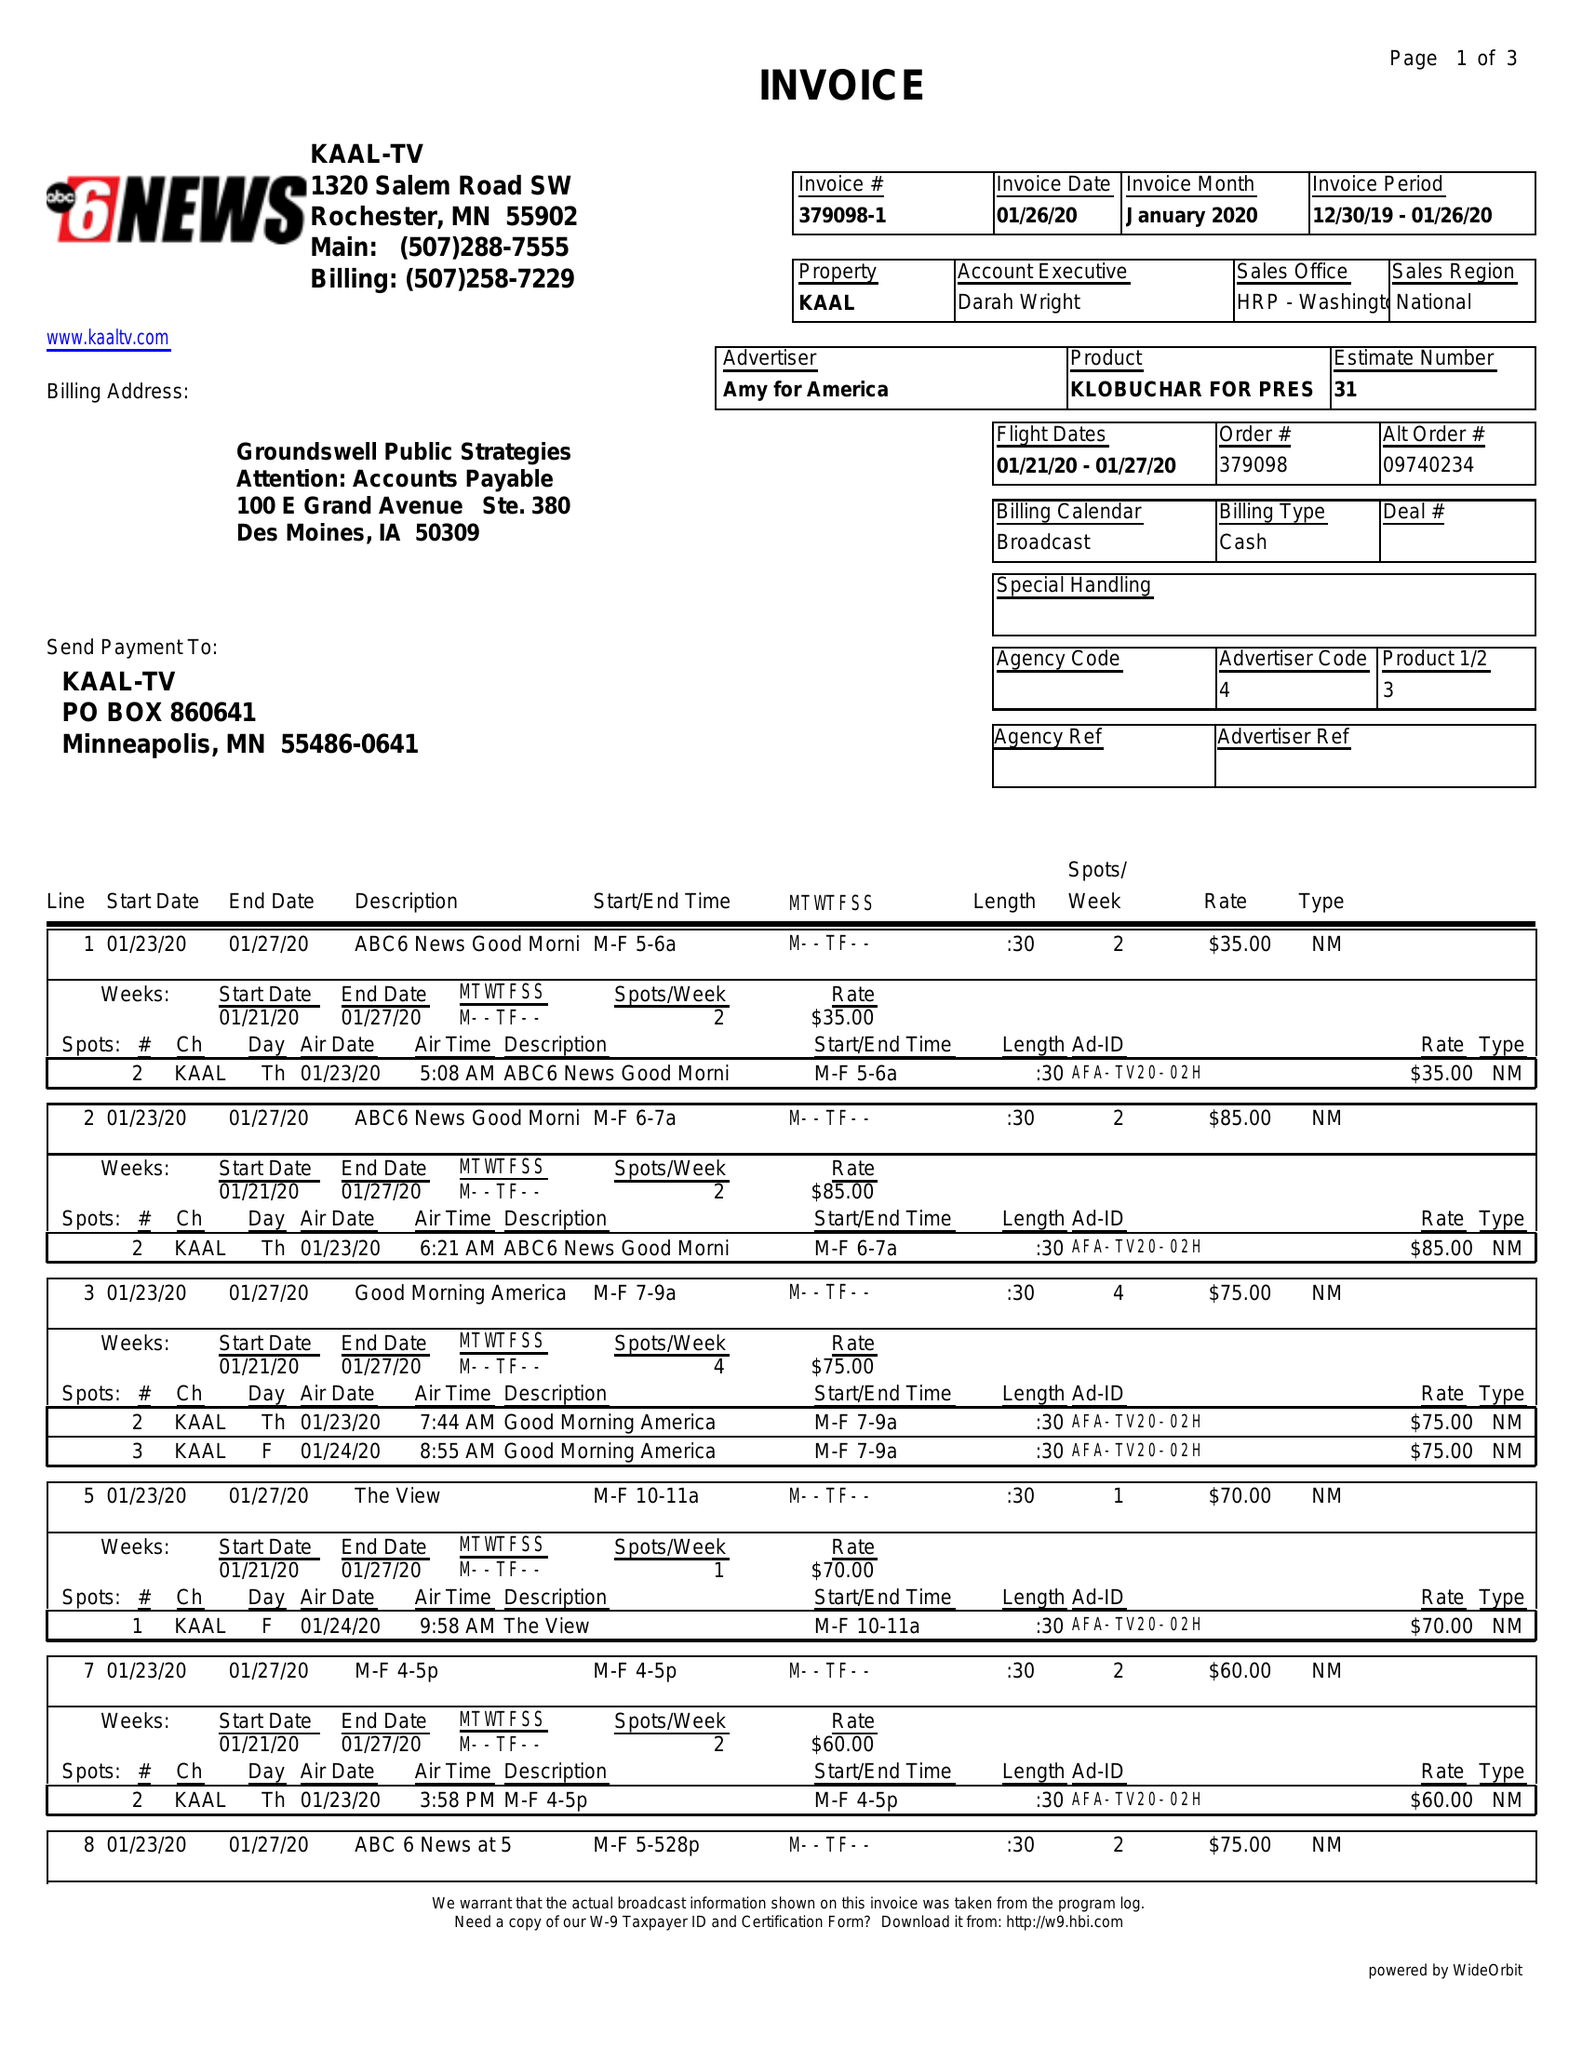What is the value for the advertiser?
Answer the question using a single word or phrase. AMY FOR AMERICA 